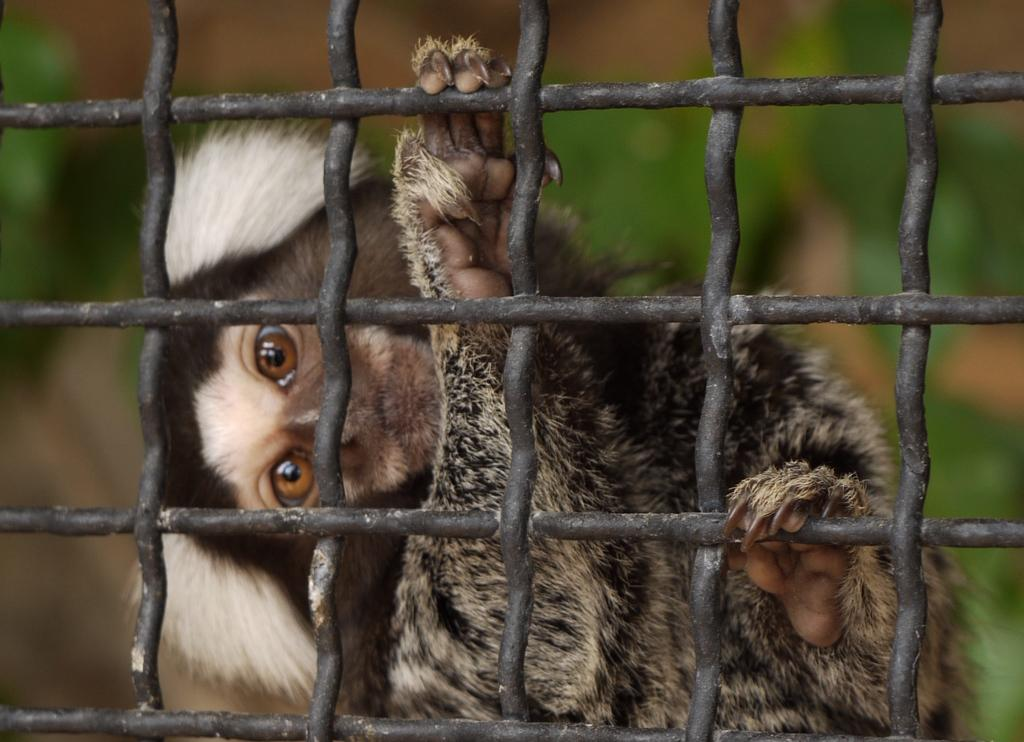What objects are in the foreground of the image? There are rods in the foreground of the image. What can be seen behind the rods? There is an animal visible behind the rods. What type of teeth can be seen on the group of nails in the image? There are no teeth or nails present in the image; it features rods and an animal behind them. 